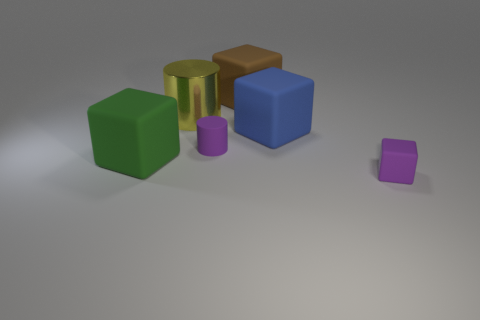Subtract all big blocks. How many blocks are left? 1 Subtract all brown blocks. How many blocks are left? 3 Add 4 big matte blocks. How many objects exist? 10 Subtract 2 cylinders. How many cylinders are left? 0 Subtract all blocks. How many objects are left? 2 Subtract 0 purple balls. How many objects are left? 6 Subtract all red cubes. Subtract all red cylinders. How many cubes are left? 4 Subtract all big brown objects. Subtract all yellow metal cubes. How many objects are left? 5 Add 6 big yellow cylinders. How many big yellow cylinders are left? 7 Add 6 blue rubber things. How many blue rubber things exist? 7 